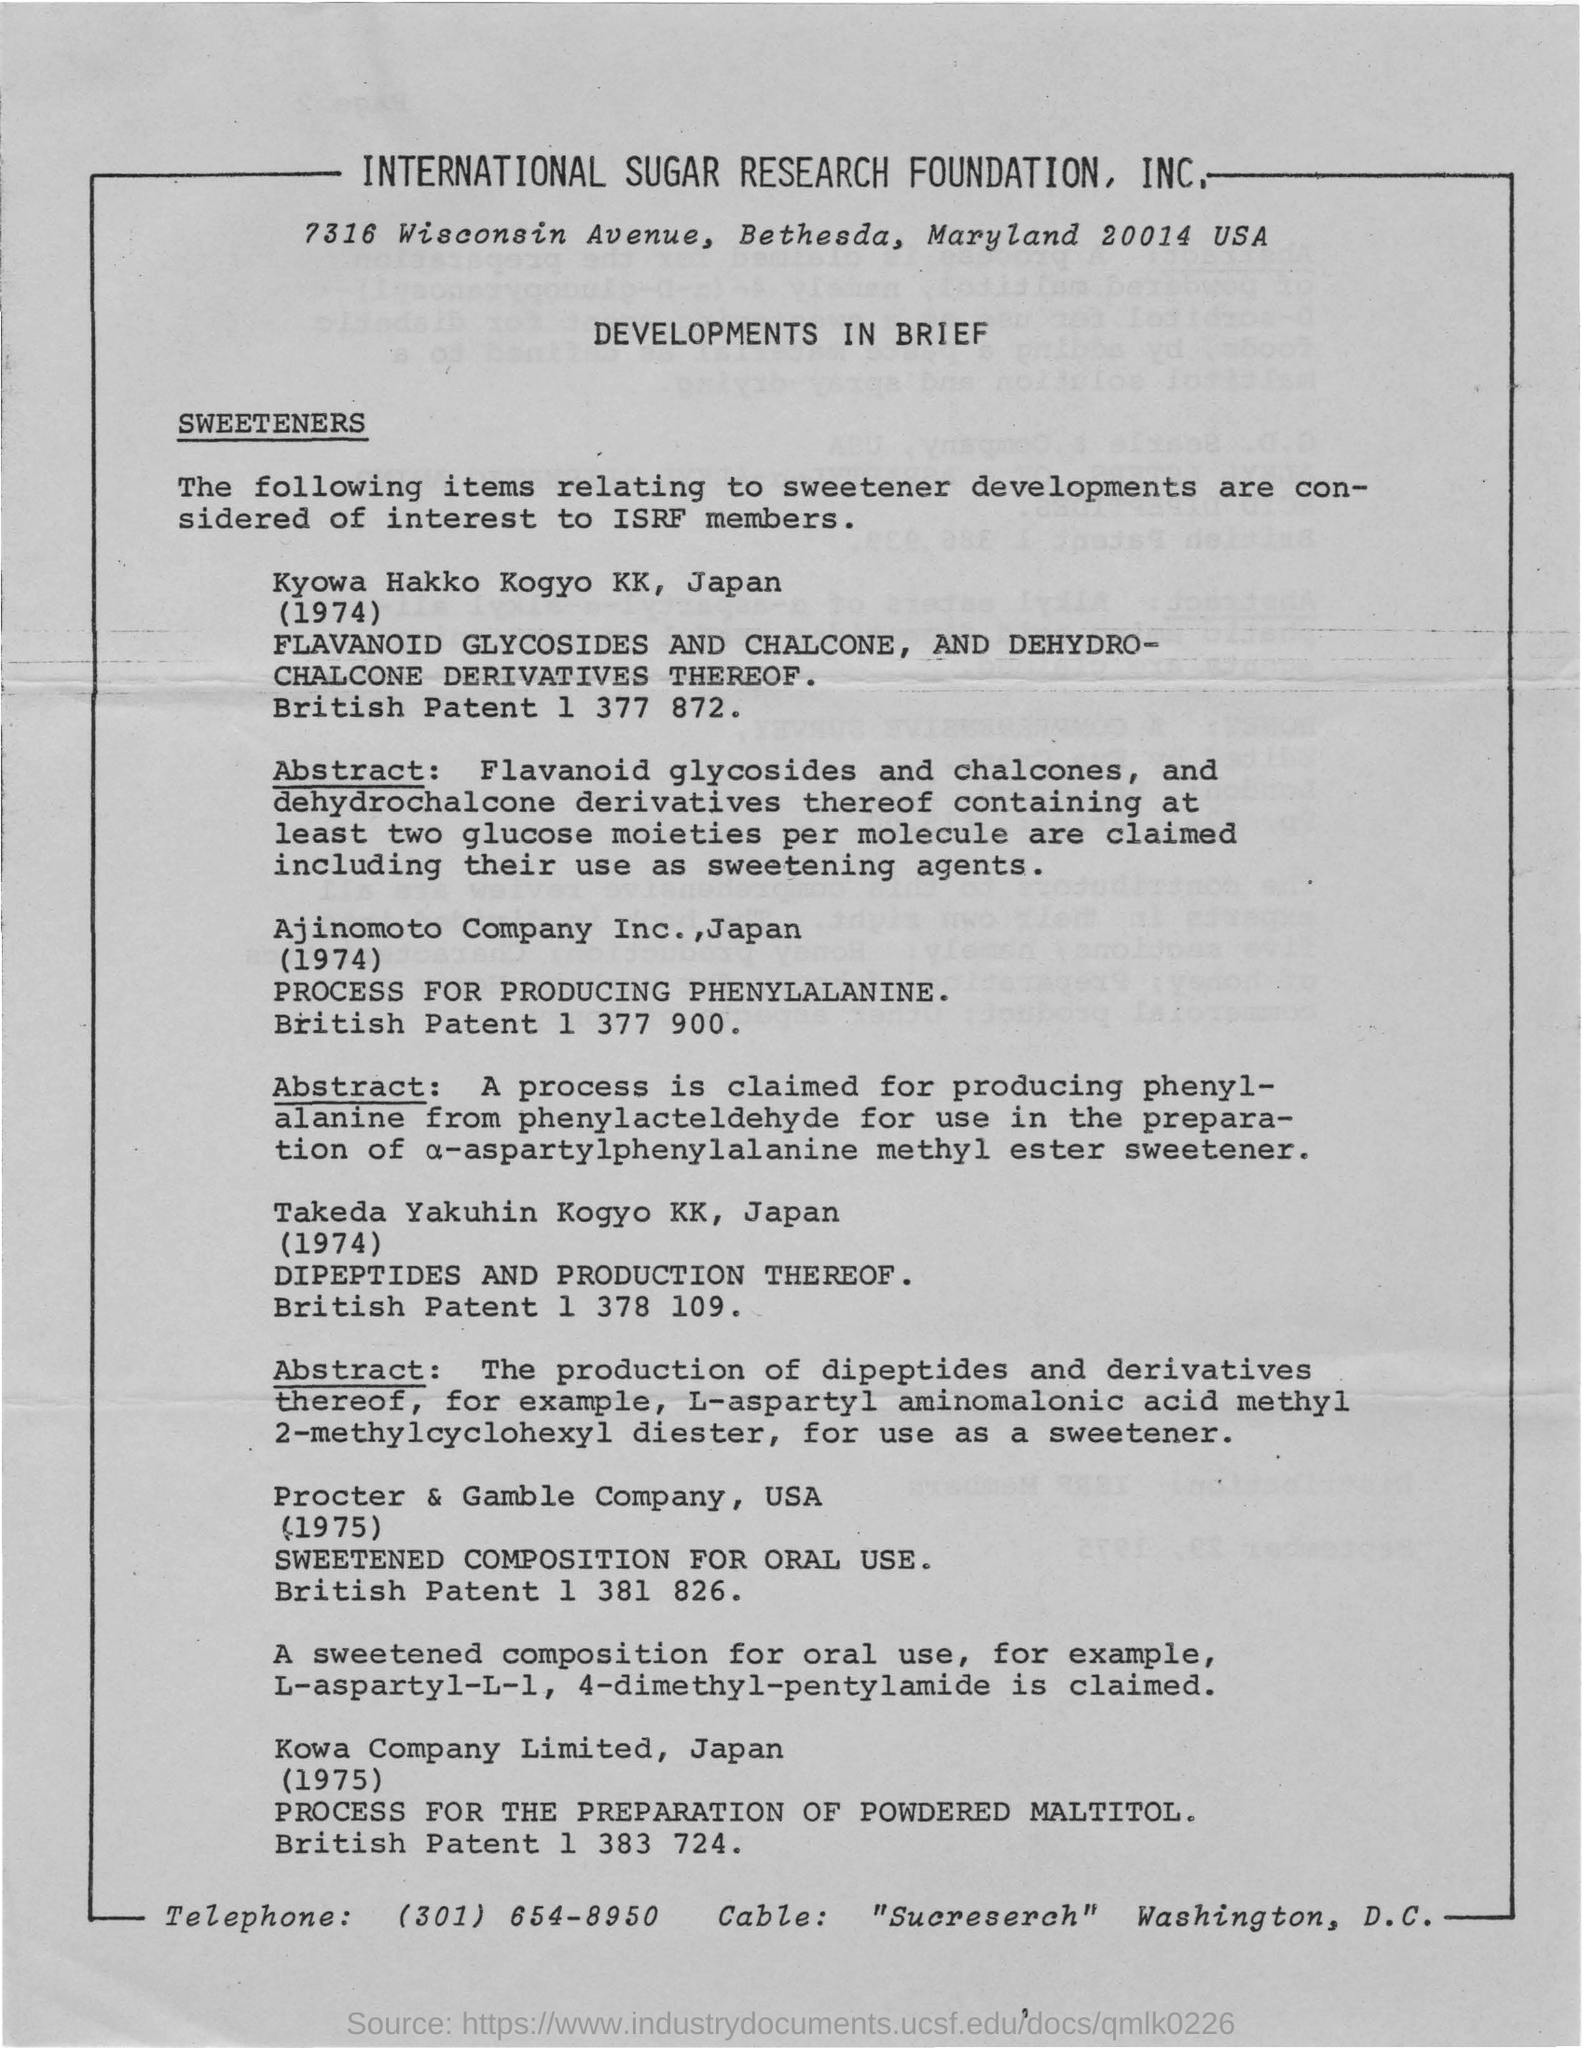Which foundation is mentioned at the top of the page?
Give a very brief answer. International Sugar Research Foundation, Inc. What is the British Patent 1 377 900?
Offer a terse response. PROCESS FOR PRODUCING PHENYLALANINE. What is the patent number of DIPEPTIDES AND PRODUCTION THEREOF?
Offer a terse response. British Patent 1 378 109. What is the sweetened composition for oral use developed by Kowa Company Limited, Japan?
Your response must be concise. L-aspartyl-L-1, 4-dimethyl-pentylamide. What is the cable given?
Offer a terse response. "Sucreserch". What is the telephone number given at the bottom?
Your answer should be compact. (301) 654-8950. 